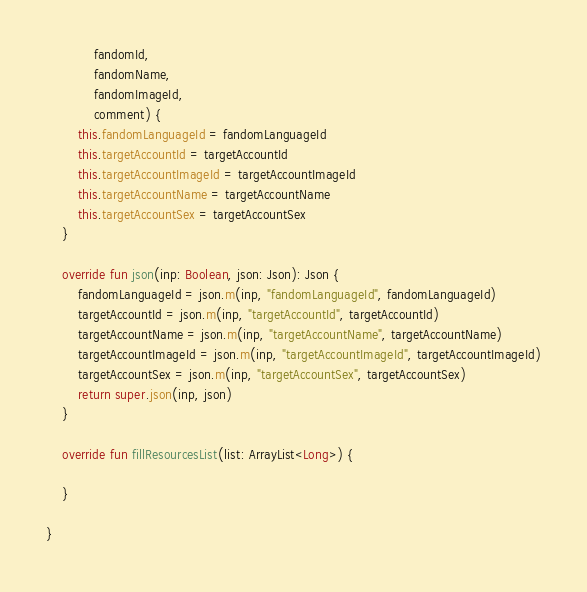Convert code to text. <code><loc_0><loc_0><loc_500><loc_500><_Kotlin_>            fandomId,
            fandomName,
            fandomImageId,
            comment) {
        this.fandomLanguageId = fandomLanguageId
        this.targetAccountId = targetAccountId
        this.targetAccountImageId = targetAccountImageId
        this.targetAccountName = targetAccountName
        this.targetAccountSex = targetAccountSex
    }

    override fun json(inp: Boolean, json: Json): Json {
        fandomLanguageId = json.m(inp, "fandomLanguageId", fandomLanguageId)
        targetAccountId = json.m(inp, "targetAccountId", targetAccountId)
        targetAccountName = json.m(inp, "targetAccountName", targetAccountName)
        targetAccountImageId = json.m(inp, "targetAccountImageId", targetAccountImageId)
        targetAccountSex = json.m(inp, "targetAccountSex", targetAccountSex)
        return super.json(inp, json)
    }

    override fun fillResourcesList(list: ArrayList<Long>) {

    }

}</code> 